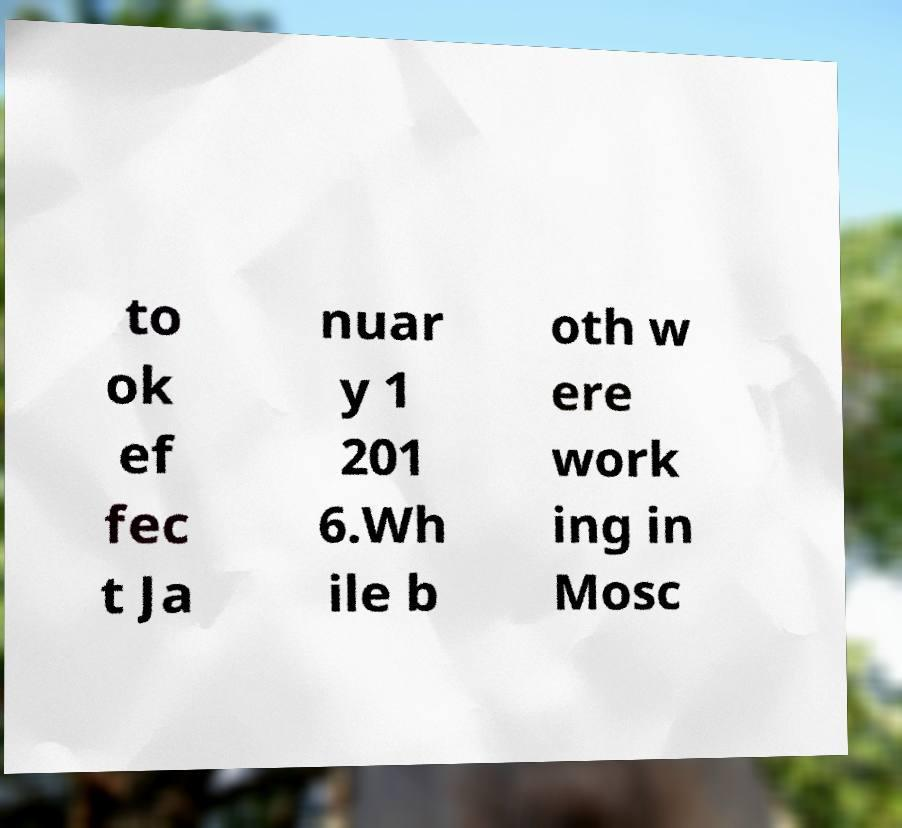Could you assist in decoding the text presented in this image and type it out clearly? to ok ef fec t Ja nuar y 1 201 6.Wh ile b oth w ere work ing in Mosc 